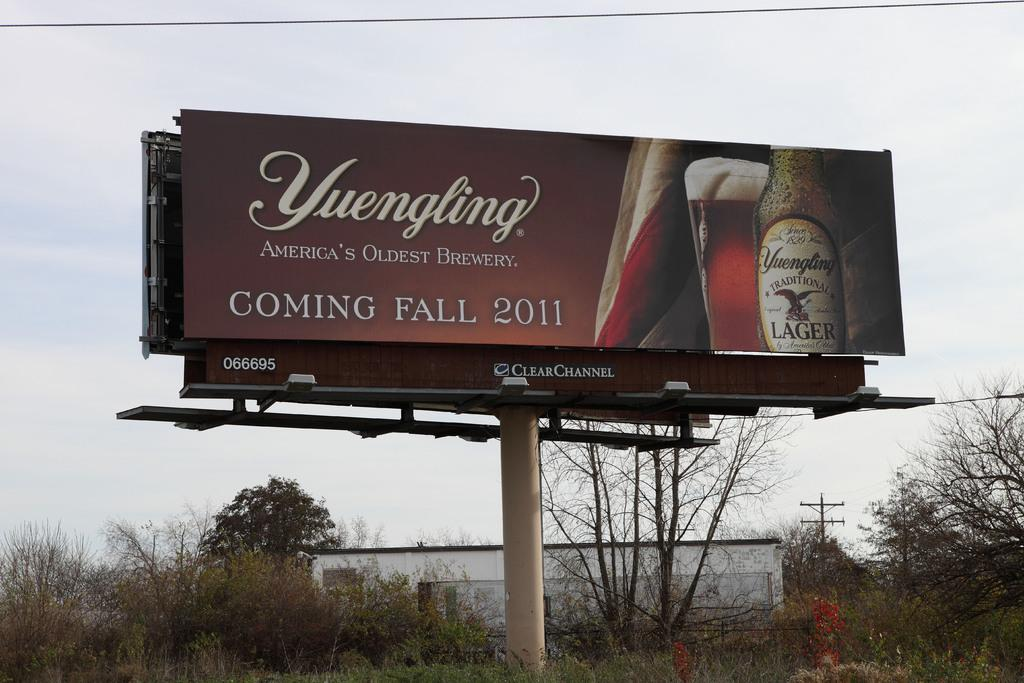<image>
Present a compact description of the photo's key features. A Yuengling billboard says something is coming in the fall of 2011. 